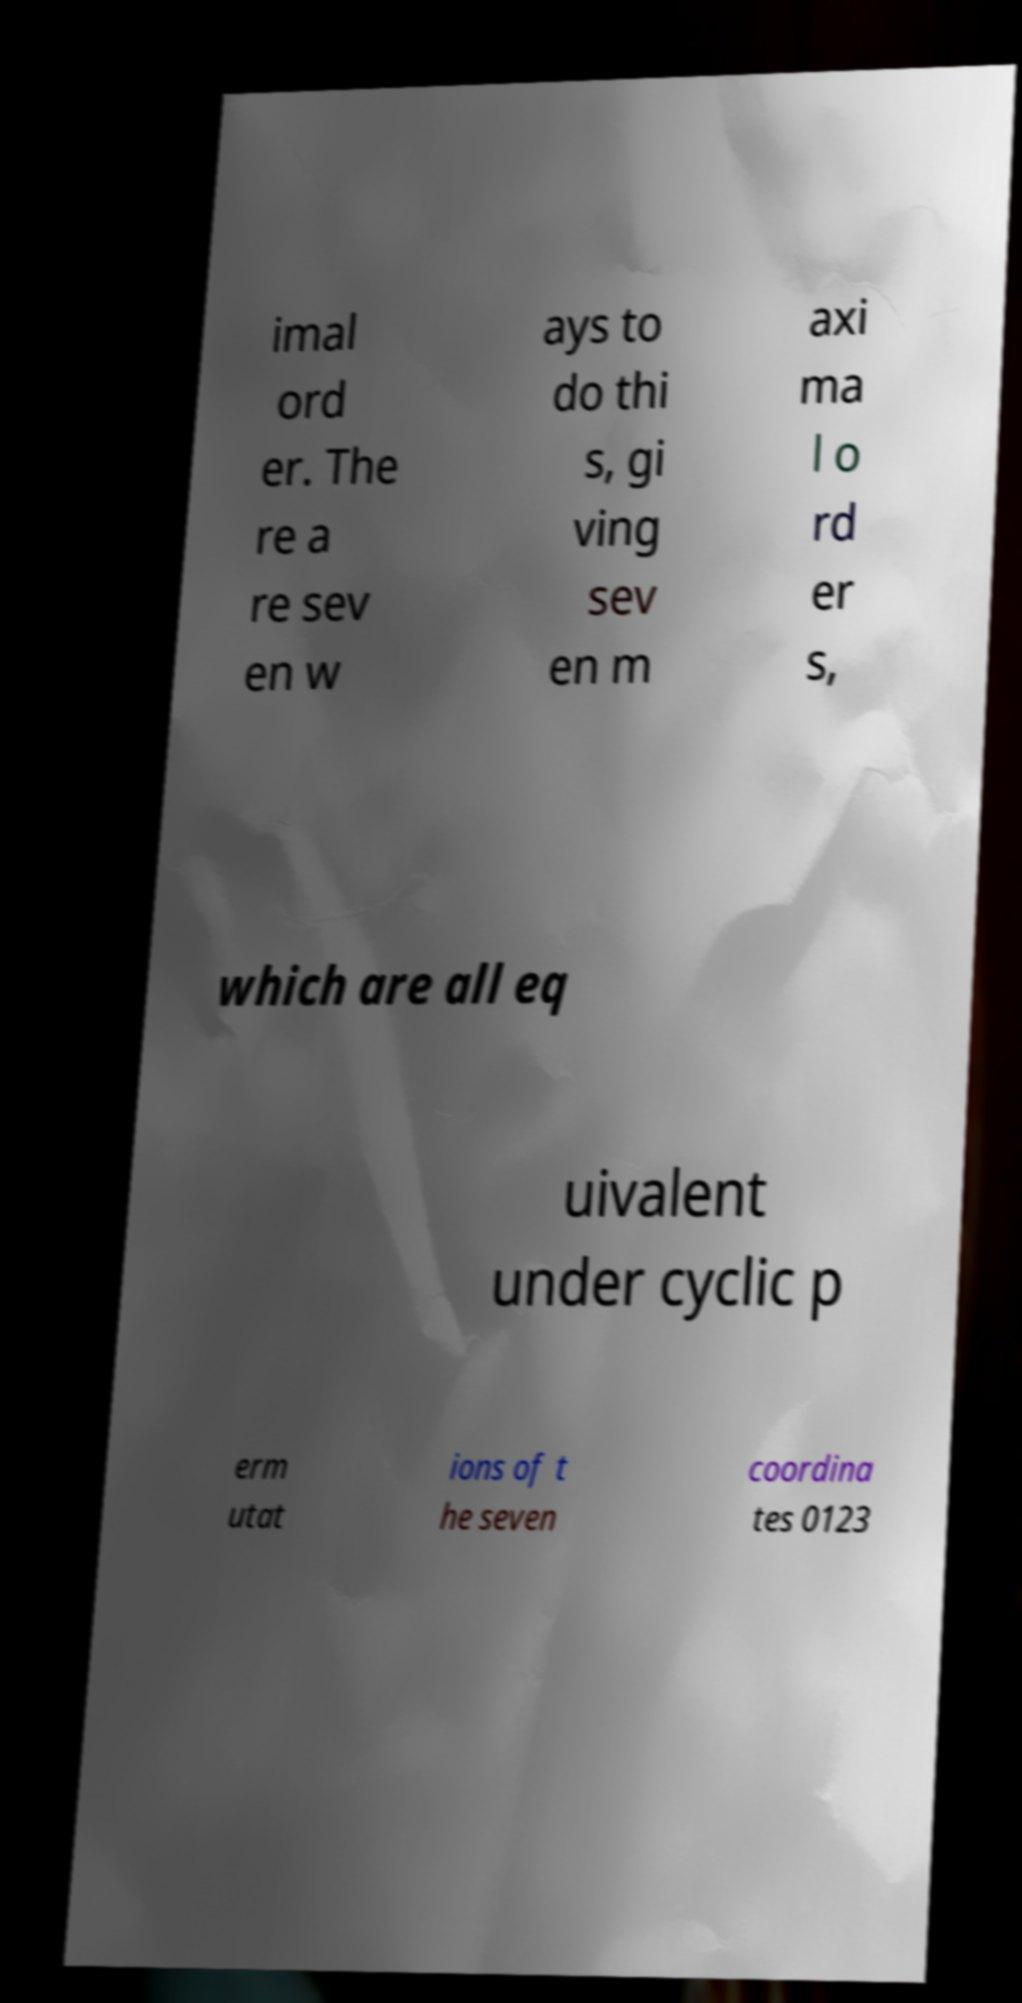Please read and relay the text visible in this image. What does it say? imal ord er. The re a re sev en w ays to do thi s, gi ving sev en m axi ma l o rd er s, which are all eq uivalent under cyclic p erm utat ions of t he seven coordina tes 0123 